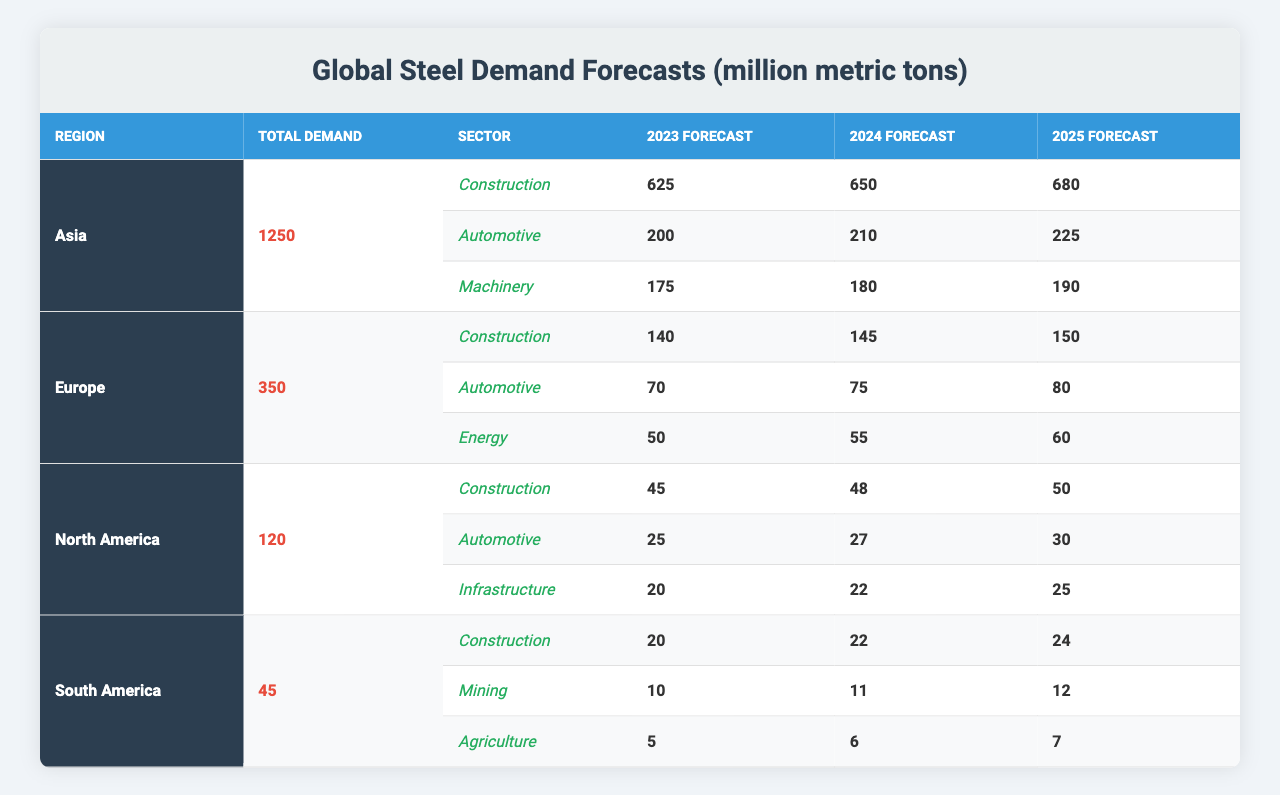What is the total steel demand forecast for Asia in 2023? According to the table, Asia's total demand forecast is listed as 1250 million metric tons, and this figure includes all end-use sectors.
Answer: 1250 What is the steel demand forecast for the construction sector in Europe in 2024? The demand for the construction sector in Europe for 2024 is explicitly stated in the table as 145 million metric tons.
Answer: 145 Which sector in North America is forecasted to have 30 million metric tons of steel demand in 2025? The automotive sector is projected to require 30 million metric tons in 2025 according to the table data.
Answer: Automotive What is the total forecast for the construction sector in South America from 2023 to 2025? The forecast amounts for 2023, 2024, and 2025 for construction sector demand are 20, 22, and 24 million metric tons, respectively. The total is calculated as 20 + 22 + 24 = 66 million metric tons.
Answer: 66 What is the average steel demand forecast for the automotive sector across all regions for 2023? In 2023, the automotive sector forecasts are 200 (Asia) + 70 (Europe) + 25 (North America) + 0 (South America, not listed) = 295 million metric tons. The average is calculated over the three regions that have data (295/3 = 98.33).
Answer: 98.33 Is the total steel demand forecast for Europe greater than that for North America? Comparing the total demand forecasts: Europe has 350 million metric tons, while North America has 120 million metric tons. Since 350 is greater than 120, the statement is true.
Answer: Yes What is the difference in steel demand forecast for the machinery sector in Asia between 2024 and 2025? The machinery sector in Asia has forecasts of 180 million metric tons for 2024 and 190 million metric tons for 2025. The difference is calculated as 190 - 180 = 10 million metric tons.
Answer: 10 Which region has the lowest total steel demand forecast? Upon inspecting the total demand values, South America has the lowest total forecast at 45 million metric tons, compared to others.
Answer: South America What percentage of Asia's total steel demand forecast in 2025 comes from the automotive sector? The automotive sector forecast for Asia in 2025 is 225 million metric tons, while the total demand forecast is 1250 million metric tons. The percentage is calculated as (225/1250) * 100 = 18%.
Answer: 18% What is the total demand forecast for the mining sector in South America across the three years? The mining sector has forecasts for 10 (2023), 11 (2024), and 12 (2025) million metric tons. The total is calculated as 10 + 11 + 12 = 33 million metric tons.
Answer: 33 